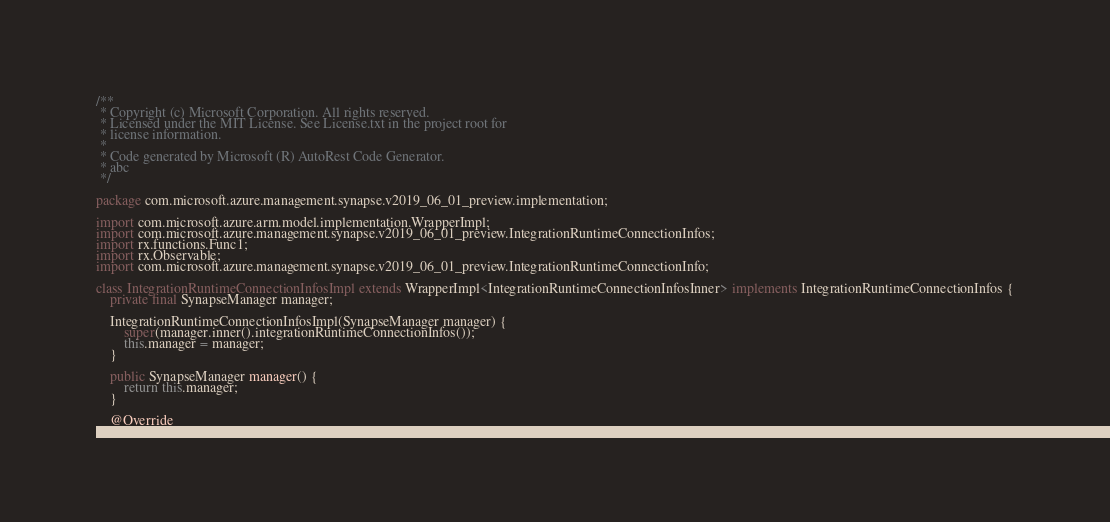<code> <loc_0><loc_0><loc_500><loc_500><_Java_>/**
 * Copyright (c) Microsoft Corporation. All rights reserved.
 * Licensed under the MIT License. See License.txt in the project root for
 * license information.
 *
 * Code generated by Microsoft (R) AutoRest Code Generator.
 * abc
 */

package com.microsoft.azure.management.synapse.v2019_06_01_preview.implementation;

import com.microsoft.azure.arm.model.implementation.WrapperImpl;
import com.microsoft.azure.management.synapse.v2019_06_01_preview.IntegrationRuntimeConnectionInfos;
import rx.functions.Func1;
import rx.Observable;
import com.microsoft.azure.management.synapse.v2019_06_01_preview.IntegrationRuntimeConnectionInfo;

class IntegrationRuntimeConnectionInfosImpl extends WrapperImpl<IntegrationRuntimeConnectionInfosInner> implements IntegrationRuntimeConnectionInfos {
    private final SynapseManager manager;

    IntegrationRuntimeConnectionInfosImpl(SynapseManager manager) {
        super(manager.inner().integrationRuntimeConnectionInfos());
        this.manager = manager;
    }

    public SynapseManager manager() {
        return this.manager;
    }

    @Override</code> 